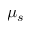Convert formula to latex. <formula><loc_0><loc_0><loc_500><loc_500>\mu _ { s }</formula> 